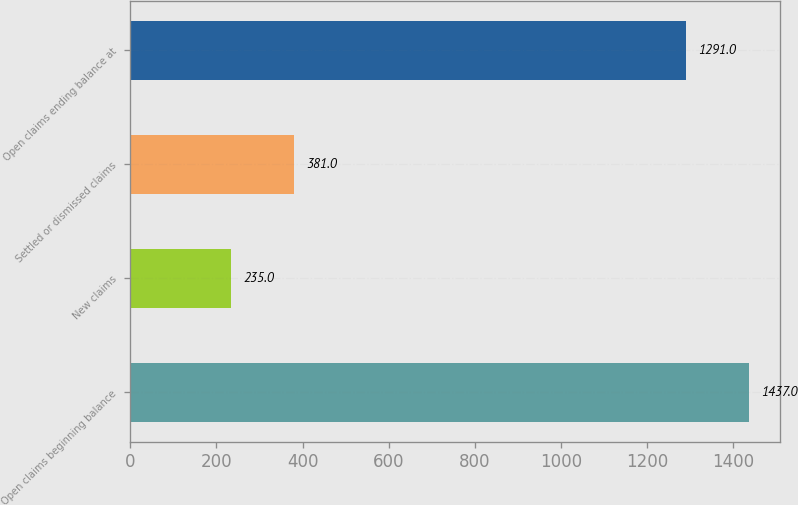Convert chart. <chart><loc_0><loc_0><loc_500><loc_500><bar_chart><fcel>Open claims beginning balance<fcel>New claims<fcel>Settled or dismissed claims<fcel>Open claims ending balance at<nl><fcel>1437<fcel>235<fcel>381<fcel>1291<nl></chart> 